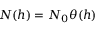Convert formula to latex. <formula><loc_0><loc_0><loc_500><loc_500>N ( h ) = N _ { 0 } \theta ( h )</formula> 